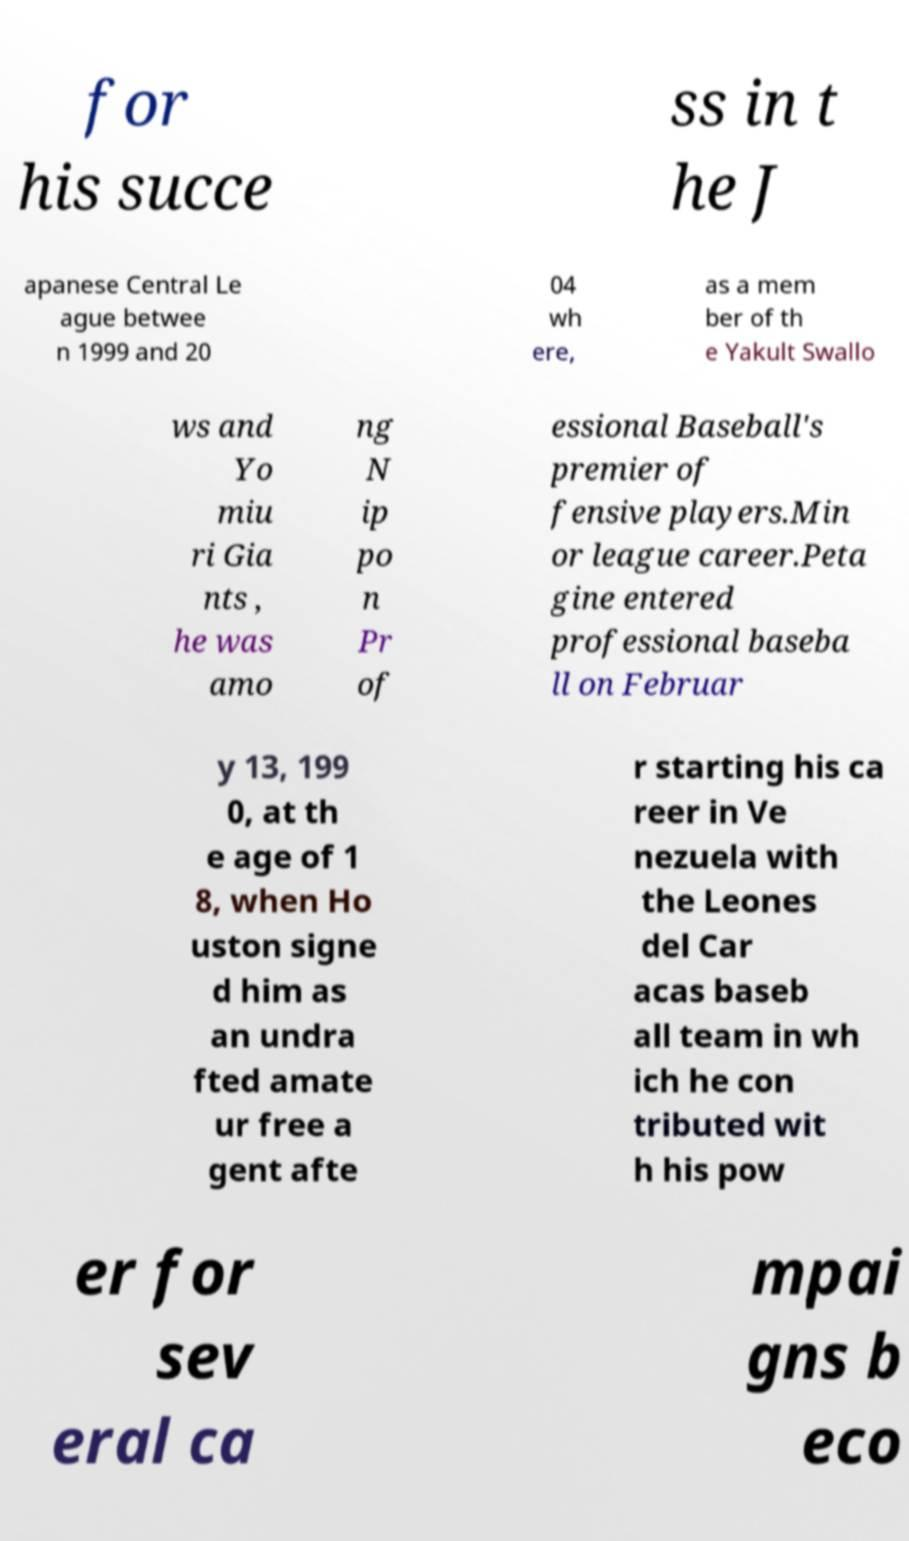Please read and relay the text visible in this image. What does it say? for his succe ss in t he J apanese Central Le ague betwee n 1999 and 20 04 wh ere, as a mem ber of th e Yakult Swallo ws and Yo miu ri Gia nts , he was amo ng N ip po n Pr of essional Baseball's premier of fensive players.Min or league career.Peta gine entered professional baseba ll on Februar y 13, 199 0, at th e age of 1 8, when Ho uston signe d him as an undra fted amate ur free a gent afte r starting his ca reer in Ve nezuela with the Leones del Car acas baseb all team in wh ich he con tributed wit h his pow er for sev eral ca mpai gns b eco 